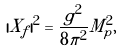Convert formula to latex. <formula><loc_0><loc_0><loc_500><loc_500>| X _ { f } | ^ { 2 } = \frac { g ^ { 2 } } { 8 \pi ^ { 2 } } M _ { p } ^ { 2 } ,</formula> 